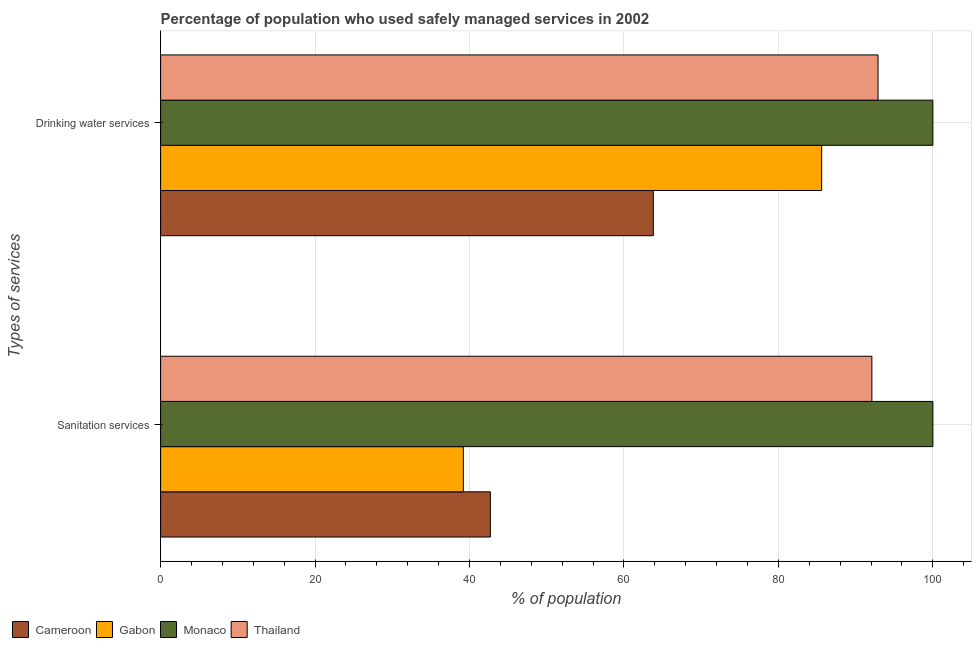How many groups of bars are there?
Give a very brief answer. 2. Are the number of bars per tick equal to the number of legend labels?
Give a very brief answer. Yes. How many bars are there on the 2nd tick from the bottom?
Your answer should be compact. 4. What is the label of the 1st group of bars from the top?
Offer a very short reply. Drinking water services. What is the percentage of population who used drinking water services in Gabon?
Make the answer very short. 85.6. Across all countries, what is the minimum percentage of population who used drinking water services?
Provide a short and direct response. 63.8. In which country was the percentage of population who used sanitation services maximum?
Your answer should be very brief. Monaco. In which country was the percentage of population who used sanitation services minimum?
Your answer should be compact. Gabon. What is the total percentage of population who used drinking water services in the graph?
Your answer should be very brief. 342.3. What is the difference between the percentage of population who used sanitation services in Gabon and that in Monaco?
Offer a terse response. -60.8. What is the difference between the percentage of population who used sanitation services in Cameroon and the percentage of population who used drinking water services in Thailand?
Make the answer very short. -50.2. What is the average percentage of population who used sanitation services per country?
Keep it short and to the point. 68.5. What is the difference between the percentage of population who used sanitation services and percentage of population who used drinking water services in Cameroon?
Offer a terse response. -21.1. In how many countries, is the percentage of population who used sanitation services greater than 24 %?
Your response must be concise. 4. What is the ratio of the percentage of population who used drinking water services in Gabon to that in Monaco?
Offer a very short reply. 0.86. What does the 3rd bar from the top in Sanitation services represents?
Provide a succinct answer. Gabon. What does the 2nd bar from the bottom in Drinking water services represents?
Your answer should be compact. Gabon. Are all the bars in the graph horizontal?
Your answer should be very brief. Yes. Does the graph contain grids?
Make the answer very short. Yes. Where does the legend appear in the graph?
Your answer should be very brief. Bottom left. How many legend labels are there?
Offer a terse response. 4. How are the legend labels stacked?
Your response must be concise. Horizontal. What is the title of the graph?
Keep it short and to the point. Percentage of population who used safely managed services in 2002. Does "Dominica" appear as one of the legend labels in the graph?
Ensure brevity in your answer.  No. What is the label or title of the X-axis?
Your answer should be very brief. % of population. What is the label or title of the Y-axis?
Keep it short and to the point. Types of services. What is the % of population of Cameroon in Sanitation services?
Give a very brief answer. 42.7. What is the % of population of Gabon in Sanitation services?
Give a very brief answer. 39.2. What is the % of population in Monaco in Sanitation services?
Keep it short and to the point. 100. What is the % of population of Thailand in Sanitation services?
Provide a succinct answer. 92.1. What is the % of population in Cameroon in Drinking water services?
Give a very brief answer. 63.8. What is the % of population in Gabon in Drinking water services?
Ensure brevity in your answer.  85.6. What is the % of population of Monaco in Drinking water services?
Provide a short and direct response. 100. What is the % of population of Thailand in Drinking water services?
Keep it short and to the point. 92.9. Across all Types of services, what is the maximum % of population in Cameroon?
Ensure brevity in your answer.  63.8. Across all Types of services, what is the maximum % of population of Gabon?
Your answer should be very brief. 85.6. Across all Types of services, what is the maximum % of population of Thailand?
Give a very brief answer. 92.9. Across all Types of services, what is the minimum % of population of Cameroon?
Your answer should be very brief. 42.7. Across all Types of services, what is the minimum % of population in Gabon?
Give a very brief answer. 39.2. Across all Types of services, what is the minimum % of population in Monaco?
Offer a very short reply. 100. Across all Types of services, what is the minimum % of population of Thailand?
Offer a terse response. 92.1. What is the total % of population of Cameroon in the graph?
Your response must be concise. 106.5. What is the total % of population in Gabon in the graph?
Provide a short and direct response. 124.8. What is the total % of population of Monaco in the graph?
Offer a terse response. 200. What is the total % of population of Thailand in the graph?
Provide a short and direct response. 185. What is the difference between the % of population in Cameroon in Sanitation services and that in Drinking water services?
Offer a terse response. -21.1. What is the difference between the % of population in Gabon in Sanitation services and that in Drinking water services?
Provide a short and direct response. -46.4. What is the difference between the % of population in Monaco in Sanitation services and that in Drinking water services?
Give a very brief answer. 0. What is the difference between the % of population in Thailand in Sanitation services and that in Drinking water services?
Keep it short and to the point. -0.8. What is the difference between the % of population of Cameroon in Sanitation services and the % of population of Gabon in Drinking water services?
Ensure brevity in your answer.  -42.9. What is the difference between the % of population in Cameroon in Sanitation services and the % of population in Monaco in Drinking water services?
Provide a short and direct response. -57.3. What is the difference between the % of population in Cameroon in Sanitation services and the % of population in Thailand in Drinking water services?
Offer a very short reply. -50.2. What is the difference between the % of population in Gabon in Sanitation services and the % of population in Monaco in Drinking water services?
Provide a succinct answer. -60.8. What is the difference between the % of population of Gabon in Sanitation services and the % of population of Thailand in Drinking water services?
Ensure brevity in your answer.  -53.7. What is the difference between the % of population of Monaco in Sanitation services and the % of population of Thailand in Drinking water services?
Make the answer very short. 7.1. What is the average % of population in Cameroon per Types of services?
Your response must be concise. 53.25. What is the average % of population in Gabon per Types of services?
Ensure brevity in your answer.  62.4. What is the average % of population of Thailand per Types of services?
Offer a terse response. 92.5. What is the difference between the % of population in Cameroon and % of population in Gabon in Sanitation services?
Give a very brief answer. 3.5. What is the difference between the % of population in Cameroon and % of population in Monaco in Sanitation services?
Provide a short and direct response. -57.3. What is the difference between the % of population in Cameroon and % of population in Thailand in Sanitation services?
Keep it short and to the point. -49.4. What is the difference between the % of population of Gabon and % of population of Monaco in Sanitation services?
Make the answer very short. -60.8. What is the difference between the % of population in Gabon and % of population in Thailand in Sanitation services?
Provide a succinct answer. -52.9. What is the difference between the % of population in Monaco and % of population in Thailand in Sanitation services?
Make the answer very short. 7.9. What is the difference between the % of population in Cameroon and % of population in Gabon in Drinking water services?
Provide a succinct answer. -21.8. What is the difference between the % of population in Cameroon and % of population in Monaco in Drinking water services?
Keep it short and to the point. -36.2. What is the difference between the % of population of Cameroon and % of population of Thailand in Drinking water services?
Your answer should be compact. -29.1. What is the difference between the % of population of Gabon and % of population of Monaco in Drinking water services?
Give a very brief answer. -14.4. What is the difference between the % of population in Gabon and % of population in Thailand in Drinking water services?
Keep it short and to the point. -7.3. What is the difference between the % of population of Monaco and % of population of Thailand in Drinking water services?
Your response must be concise. 7.1. What is the ratio of the % of population of Cameroon in Sanitation services to that in Drinking water services?
Offer a terse response. 0.67. What is the ratio of the % of population in Gabon in Sanitation services to that in Drinking water services?
Offer a terse response. 0.46. What is the ratio of the % of population of Monaco in Sanitation services to that in Drinking water services?
Provide a succinct answer. 1. What is the ratio of the % of population in Thailand in Sanitation services to that in Drinking water services?
Make the answer very short. 0.99. What is the difference between the highest and the second highest % of population in Cameroon?
Offer a very short reply. 21.1. What is the difference between the highest and the second highest % of population of Gabon?
Keep it short and to the point. 46.4. What is the difference between the highest and the second highest % of population of Thailand?
Offer a very short reply. 0.8. What is the difference between the highest and the lowest % of population in Cameroon?
Your answer should be compact. 21.1. What is the difference between the highest and the lowest % of population of Gabon?
Keep it short and to the point. 46.4. What is the difference between the highest and the lowest % of population in Monaco?
Provide a short and direct response. 0. What is the difference between the highest and the lowest % of population in Thailand?
Offer a very short reply. 0.8. 